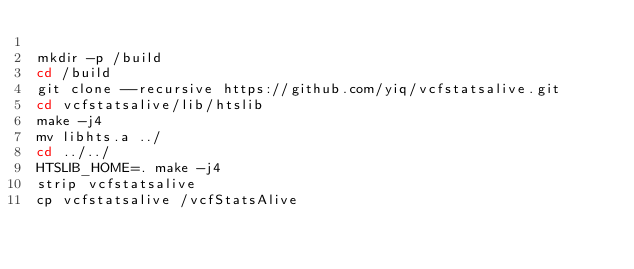<code> <loc_0><loc_0><loc_500><loc_500><_Bash_>
mkdir -p /build
cd /build
git clone --recursive https://github.com/yiq/vcfstatsalive.git
cd vcfstatsalive/lib/htslib
make -j4
mv libhts.a ../
cd ../../
HTSLIB_HOME=. make -j4
strip vcfstatsalive
cp vcfstatsalive /vcfStatsAlive
</code> 